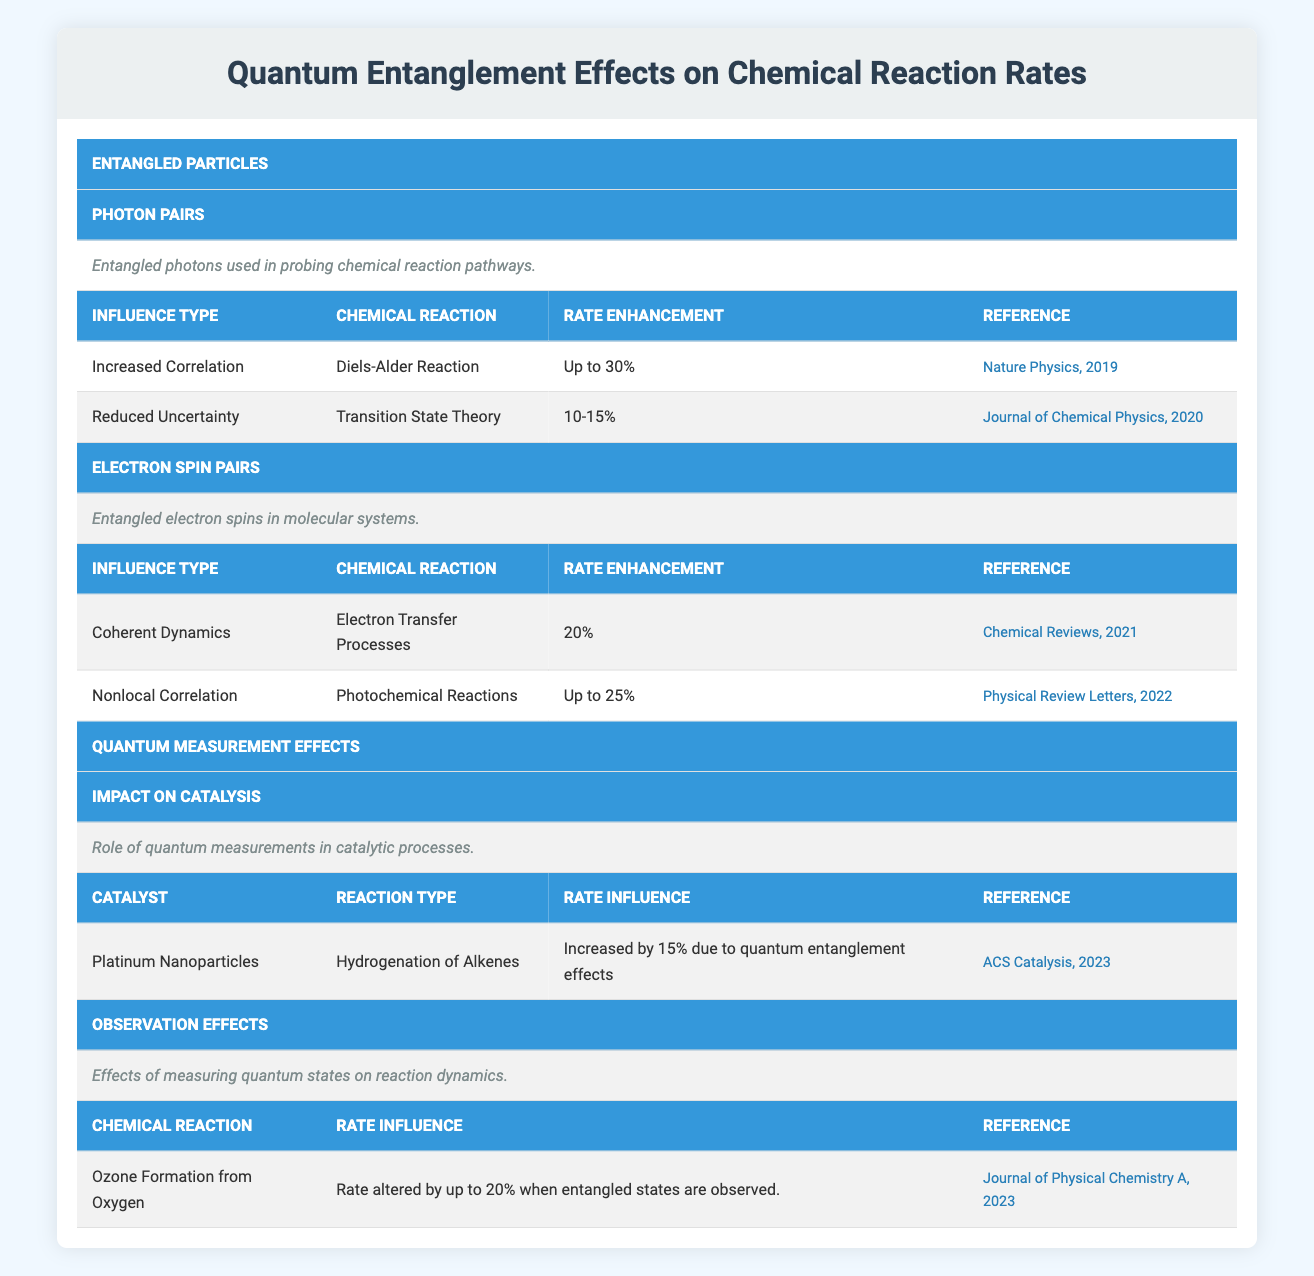What is the maximum rate enhancement reported for the Diels-Alder reaction? The table lists the Diels-Alder reaction under the "Increased Correlation" influence of photon pairs, which indicates a maximum rate enhancement of "Up to 30%" according to the reference provided.
Answer: Up to 30% How much is the rate enhancement for electron transfer processes? Looking under the "Influence on Reaction Rate" for electron spin pairs, the rate enhancement for electron transfer processes is specified as "20%" from the reference.
Answer: 20% Is the rate of hydrogenation of alkenes influenced by quantum entanglement effects? The table provides information under "Impact on Catalysis," indicating that the rate of hydrogenation of alkenes is indeed influenced, specifically increased by 15% due to quantum entanglement effects.
Answer: Yes What is the average rate enhancement for the reactions listed under photon pairs? There are two rate enhancements given for photon pairs: "Up to 30%" and "10-15%". To find the average: convert these ranges: 30 and the average of 10-15 is 12.5. The sum of 30 and 12.5 is 42.5. Dividing by 2 gives an average of 21.25.
Answer: 21.25 How does the rate influence of observing entangled states affect ozone formation from oxygen? Under "Observation Effects," the rate influence is documented as "Rate altered by up to 20% when entangled states are observed." This establishes the specific effect on ozone formation when entangled states are measured.
Answer: Up to 20% What reaction benefits from nonlocal correlation, and what is its rate enhancement? The table shows that photochemical reactions benefit from nonlocal correlation listed under electron spin pairs, with a rate enhancement of "Up to 25%."
Answer: Photochemical Reactions, Up to 25% Which reference mentions the increased correlation effect on the Diels-Alder reaction? Cross-referencing the Diels-Alder reaction data in the table, it specifies that the "Increased Correlation" influence has its reference from "Nature Physics, 2019."
Answer: Nature Physics, 2019 Which quantum measurement effect results in a 15% increase when using platinum nanoparticles? The table informs us that the "Impact on Catalysis" which describes the role of quantum measurement in catalytic processes resulting in a 15% increase corresponds to platinum nanoparticles used in the hydrogenation of alkenes.
Answer: Platinum Nanoparticles, 15% What type of reaction is influenced under observation effects and by what percentage? According to the "Observation Effects," the chemical reaction influenced is the ozone formation from oxygen, with a rate altered by "up to 20%" when observing entangled states.
Answer: Ozone Formation from Oxygen, up to 20% 